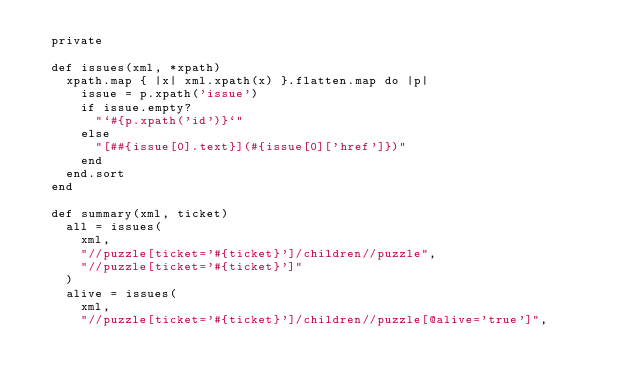Convert code to text. <code><loc_0><loc_0><loc_500><loc_500><_Ruby_>  private

  def issues(xml, *xpath)
    xpath.map { |x| xml.xpath(x) }.flatten.map do |p|
      issue = p.xpath('issue')
      if issue.empty?
        "`#{p.xpath('id')}`"
      else
        "[##{issue[0].text}](#{issue[0]['href']})"
      end
    end.sort
  end

  def summary(xml, ticket)
    all = issues(
      xml,
      "//puzzle[ticket='#{ticket}']/children//puzzle",
      "//puzzle[ticket='#{ticket}']"
    )
    alive = issues(
      xml,
      "//puzzle[ticket='#{ticket}']/children//puzzle[@alive='true']",</code> 